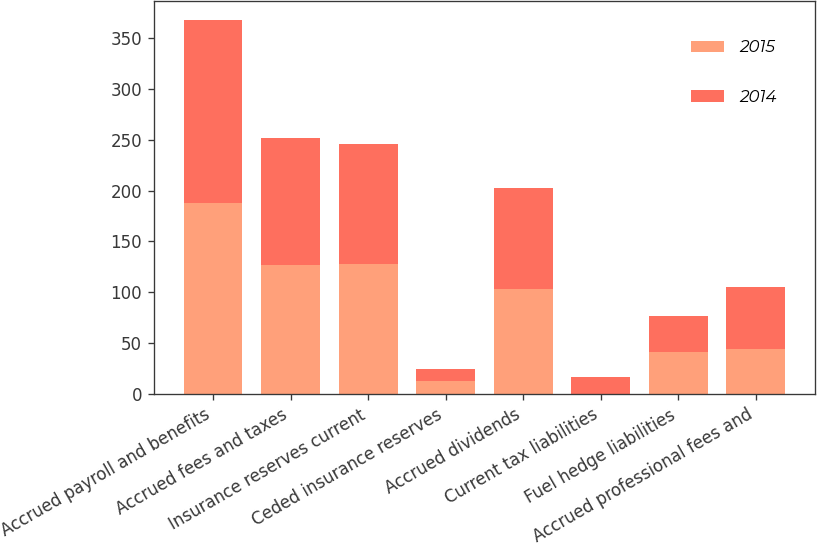<chart> <loc_0><loc_0><loc_500><loc_500><stacked_bar_chart><ecel><fcel>Accrued payroll and benefits<fcel>Accrued fees and taxes<fcel>Insurance reserves current<fcel>Ceded insurance reserves<fcel>Accrued dividends<fcel>Current tax liabilities<fcel>Fuel hedge liabilities<fcel>Accrued professional fees and<nl><fcel>2015<fcel>187.8<fcel>126.5<fcel>127.7<fcel>12.5<fcel>103.7<fcel>0.5<fcel>41<fcel>44.2<nl><fcel>2014<fcel>180.2<fcel>125.6<fcel>118.6<fcel>12.4<fcel>98.7<fcel>16.3<fcel>35.3<fcel>61.2<nl></chart> 